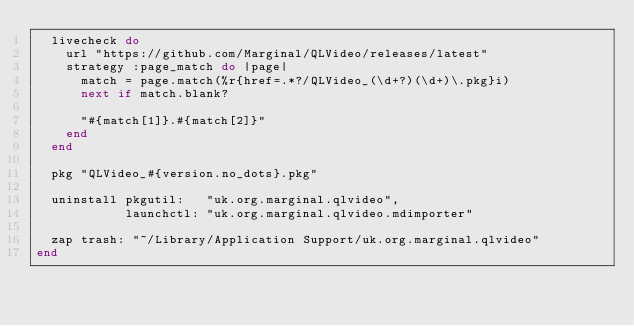<code> <loc_0><loc_0><loc_500><loc_500><_Ruby_>  livecheck do
    url "https://github.com/Marginal/QLVideo/releases/latest"
    strategy :page_match do |page|
      match = page.match(%r{href=.*?/QLVideo_(\d+?)(\d+)\.pkg}i)
      next if match.blank?

      "#{match[1]}.#{match[2]}"
    end
  end

  pkg "QLVideo_#{version.no_dots}.pkg"

  uninstall pkgutil:   "uk.org.marginal.qlvideo",
            launchctl: "uk.org.marginal.qlvideo.mdimporter"

  zap trash: "~/Library/Application Support/uk.org.marginal.qlvideo"
end
</code> 